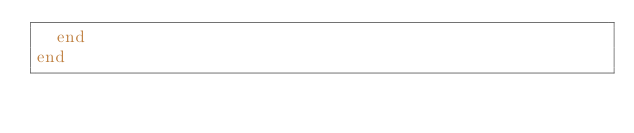<code> <loc_0><loc_0><loc_500><loc_500><_Ruby_>  end
end
</code> 